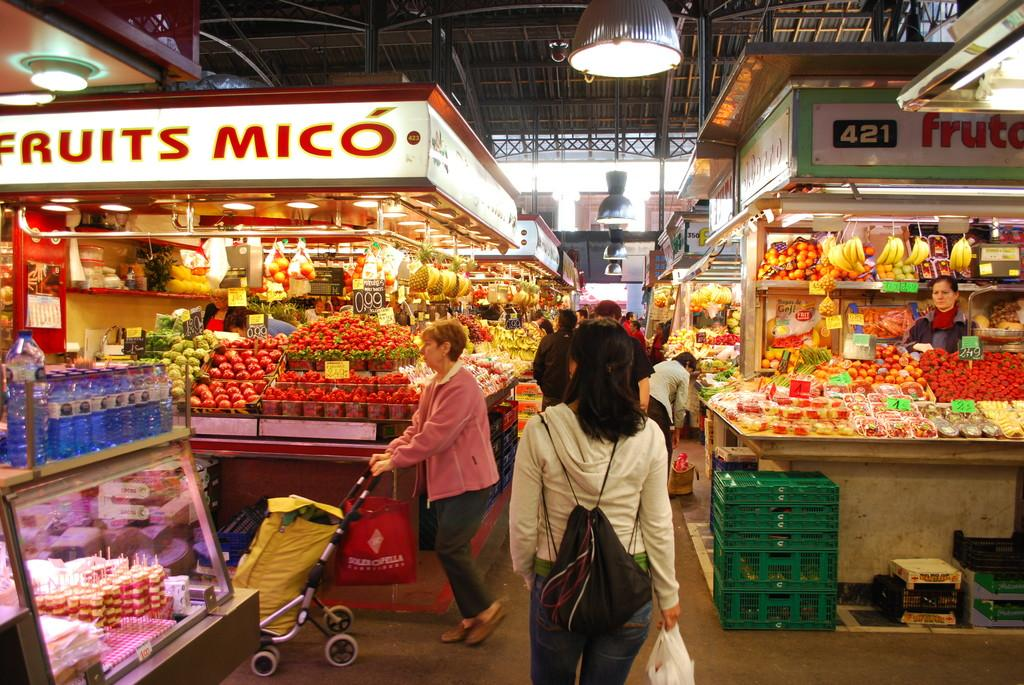<image>
Render a clear and concise summary of the photo. People shopping in a fruit aisle that says 421 fruit. 